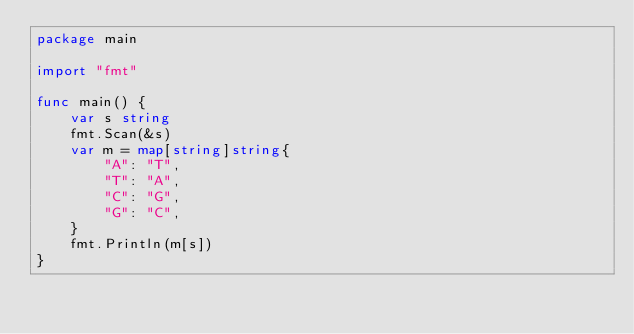<code> <loc_0><loc_0><loc_500><loc_500><_Go_>package main

import "fmt"

func main() {
	var s string
	fmt.Scan(&s)
	var m = map[string]string{
		"A": "T",
		"T": "A",
		"C": "G",
		"G": "C",
	}
	fmt.Println(m[s])
}
</code> 